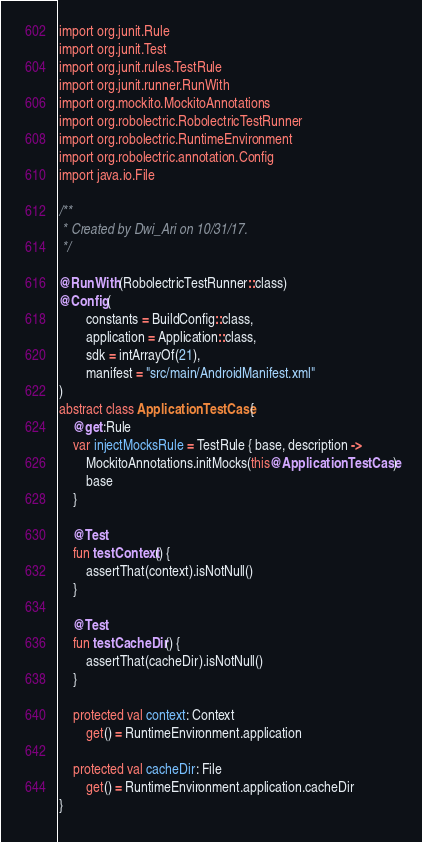<code> <loc_0><loc_0><loc_500><loc_500><_Kotlin_>import org.junit.Rule
import org.junit.Test
import org.junit.rules.TestRule
import org.junit.runner.RunWith
import org.mockito.MockitoAnnotations
import org.robolectric.RobolectricTestRunner
import org.robolectric.RuntimeEnvironment
import org.robolectric.annotation.Config
import java.io.File

/**
 * Created by Dwi_Ari on 10/31/17.
 */

@RunWith(RobolectricTestRunner::class)
@Config(
        constants = BuildConfig::class,
        application = Application::class,
        sdk = intArrayOf(21),
        manifest = "src/main/AndroidManifest.xml"
)
abstract class ApplicationTestCase {
    @get:Rule
    var injectMocksRule = TestRule { base, description ->
        MockitoAnnotations.initMocks(this@ApplicationTestCase)
        base
    }

    @Test
    fun testContext() {
        assertThat(context).isNotNull()
    }

    @Test
    fun testCacheDir() {
        assertThat(cacheDir).isNotNull()
    }

    protected val context: Context
        get() = RuntimeEnvironment.application

    protected val cacheDir: File
        get() = RuntimeEnvironment.application.cacheDir
}</code> 